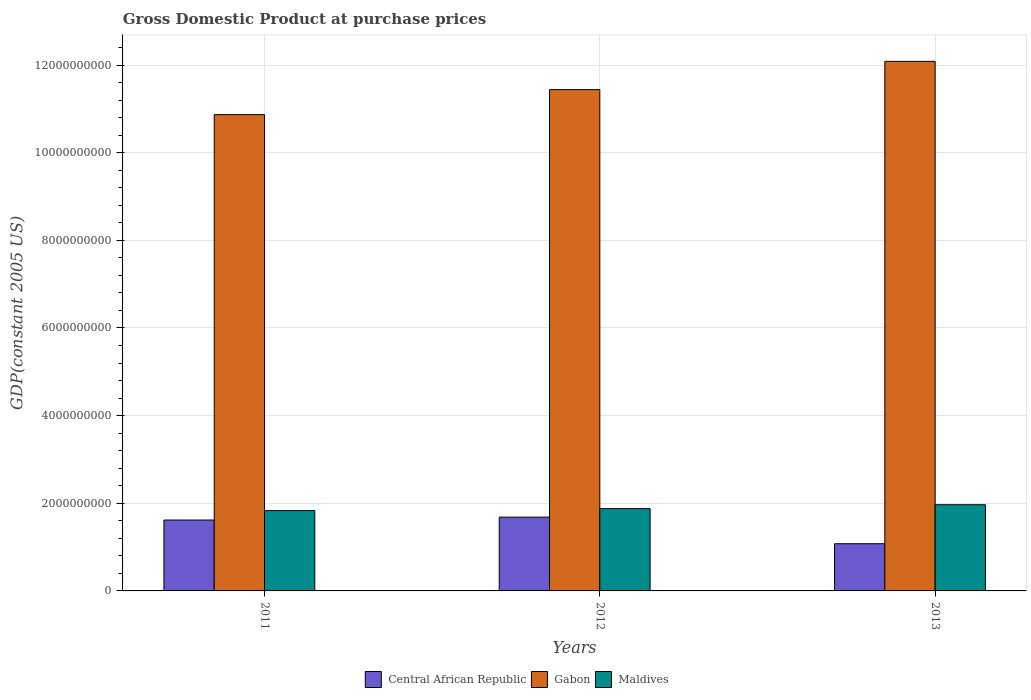How many different coloured bars are there?
Your response must be concise. 3. Are the number of bars per tick equal to the number of legend labels?
Provide a succinct answer. Yes. How many bars are there on the 1st tick from the left?
Provide a succinct answer. 3. How many bars are there on the 2nd tick from the right?
Your answer should be compact. 3. In how many cases, is the number of bars for a given year not equal to the number of legend labels?
Provide a short and direct response. 0. What is the GDP at purchase prices in Maldives in 2011?
Keep it short and to the point. 1.83e+09. Across all years, what is the maximum GDP at purchase prices in Gabon?
Provide a short and direct response. 1.21e+1. Across all years, what is the minimum GDP at purchase prices in Maldives?
Your answer should be very brief. 1.83e+09. In which year was the GDP at purchase prices in Gabon maximum?
Provide a succinct answer. 2013. In which year was the GDP at purchase prices in Gabon minimum?
Ensure brevity in your answer.  2011. What is the total GDP at purchase prices in Maldives in the graph?
Provide a short and direct response. 5.68e+09. What is the difference between the GDP at purchase prices in Maldives in 2011 and that in 2013?
Provide a short and direct response. -1.34e+08. What is the difference between the GDP at purchase prices in Maldives in 2012 and the GDP at purchase prices in Gabon in 2013?
Provide a succinct answer. -1.02e+1. What is the average GDP at purchase prices in Gabon per year?
Your answer should be compact. 1.15e+1. In the year 2011, what is the difference between the GDP at purchase prices in Central African Republic and GDP at purchase prices in Maldives?
Keep it short and to the point. -2.15e+08. In how many years, is the GDP at purchase prices in Central African Republic greater than 7600000000 US$?
Offer a very short reply. 0. What is the ratio of the GDP at purchase prices in Maldives in 2012 to that in 2013?
Your response must be concise. 0.96. Is the GDP at purchase prices in Maldives in 2011 less than that in 2012?
Provide a short and direct response. Yes. What is the difference between the highest and the second highest GDP at purchase prices in Maldives?
Offer a very short reply. 8.83e+07. What is the difference between the highest and the lowest GDP at purchase prices in Maldives?
Offer a very short reply. 1.34e+08. In how many years, is the GDP at purchase prices in Central African Republic greater than the average GDP at purchase prices in Central African Republic taken over all years?
Keep it short and to the point. 2. What does the 2nd bar from the left in 2012 represents?
Offer a very short reply. Gabon. What does the 2nd bar from the right in 2013 represents?
Offer a terse response. Gabon. Is it the case that in every year, the sum of the GDP at purchase prices in Maldives and GDP at purchase prices in Gabon is greater than the GDP at purchase prices in Central African Republic?
Your response must be concise. Yes. Are all the bars in the graph horizontal?
Make the answer very short. No. What is the difference between two consecutive major ticks on the Y-axis?
Keep it short and to the point. 2.00e+09. Are the values on the major ticks of Y-axis written in scientific E-notation?
Your answer should be compact. No. Does the graph contain any zero values?
Offer a very short reply. No. Does the graph contain grids?
Give a very brief answer. Yes. Where does the legend appear in the graph?
Your response must be concise. Bottom center. How many legend labels are there?
Ensure brevity in your answer.  3. What is the title of the graph?
Provide a short and direct response. Gross Domestic Product at purchase prices. Does "El Salvador" appear as one of the legend labels in the graph?
Provide a short and direct response. No. What is the label or title of the X-axis?
Your answer should be very brief. Years. What is the label or title of the Y-axis?
Provide a short and direct response. GDP(constant 2005 US). What is the GDP(constant 2005 US) in Central African Republic in 2011?
Ensure brevity in your answer.  1.62e+09. What is the GDP(constant 2005 US) in Gabon in 2011?
Offer a very short reply. 1.09e+1. What is the GDP(constant 2005 US) of Maldives in 2011?
Ensure brevity in your answer.  1.83e+09. What is the GDP(constant 2005 US) in Central African Republic in 2012?
Provide a short and direct response. 1.68e+09. What is the GDP(constant 2005 US) of Gabon in 2012?
Provide a short and direct response. 1.14e+1. What is the GDP(constant 2005 US) of Maldives in 2012?
Give a very brief answer. 1.88e+09. What is the GDP(constant 2005 US) in Central African Republic in 2013?
Keep it short and to the point. 1.08e+09. What is the GDP(constant 2005 US) in Gabon in 2013?
Give a very brief answer. 1.21e+1. What is the GDP(constant 2005 US) of Maldives in 2013?
Keep it short and to the point. 1.97e+09. Across all years, what is the maximum GDP(constant 2005 US) of Central African Republic?
Offer a terse response. 1.68e+09. Across all years, what is the maximum GDP(constant 2005 US) in Gabon?
Your answer should be very brief. 1.21e+1. Across all years, what is the maximum GDP(constant 2005 US) of Maldives?
Keep it short and to the point. 1.97e+09. Across all years, what is the minimum GDP(constant 2005 US) in Central African Republic?
Offer a very short reply. 1.08e+09. Across all years, what is the minimum GDP(constant 2005 US) in Gabon?
Provide a succinct answer. 1.09e+1. Across all years, what is the minimum GDP(constant 2005 US) of Maldives?
Offer a very short reply. 1.83e+09. What is the total GDP(constant 2005 US) in Central African Republic in the graph?
Offer a very short reply. 4.38e+09. What is the total GDP(constant 2005 US) in Gabon in the graph?
Provide a short and direct response. 3.44e+1. What is the total GDP(constant 2005 US) in Maldives in the graph?
Offer a terse response. 5.68e+09. What is the difference between the GDP(constant 2005 US) of Central African Republic in 2011 and that in 2012?
Keep it short and to the point. -6.65e+07. What is the difference between the GDP(constant 2005 US) of Gabon in 2011 and that in 2012?
Provide a short and direct response. -5.71e+08. What is the difference between the GDP(constant 2005 US) of Maldives in 2011 and that in 2012?
Your answer should be very brief. -4.57e+07. What is the difference between the GDP(constant 2005 US) in Central African Republic in 2011 and that in 2013?
Make the answer very short. 5.41e+08. What is the difference between the GDP(constant 2005 US) of Gabon in 2011 and that in 2013?
Keep it short and to the point. -1.22e+09. What is the difference between the GDP(constant 2005 US) of Maldives in 2011 and that in 2013?
Keep it short and to the point. -1.34e+08. What is the difference between the GDP(constant 2005 US) of Central African Republic in 2012 and that in 2013?
Ensure brevity in your answer.  6.07e+08. What is the difference between the GDP(constant 2005 US) of Gabon in 2012 and that in 2013?
Your response must be concise. -6.45e+08. What is the difference between the GDP(constant 2005 US) in Maldives in 2012 and that in 2013?
Offer a very short reply. -8.83e+07. What is the difference between the GDP(constant 2005 US) in Central African Republic in 2011 and the GDP(constant 2005 US) in Gabon in 2012?
Offer a terse response. -9.82e+09. What is the difference between the GDP(constant 2005 US) in Central African Republic in 2011 and the GDP(constant 2005 US) in Maldives in 2012?
Your answer should be very brief. -2.61e+08. What is the difference between the GDP(constant 2005 US) in Gabon in 2011 and the GDP(constant 2005 US) in Maldives in 2012?
Provide a succinct answer. 8.99e+09. What is the difference between the GDP(constant 2005 US) of Central African Republic in 2011 and the GDP(constant 2005 US) of Gabon in 2013?
Give a very brief answer. -1.05e+1. What is the difference between the GDP(constant 2005 US) in Central African Republic in 2011 and the GDP(constant 2005 US) in Maldives in 2013?
Provide a short and direct response. -3.49e+08. What is the difference between the GDP(constant 2005 US) in Gabon in 2011 and the GDP(constant 2005 US) in Maldives in 2013?
Provide a succinct answer. 8.90e+09. What is the difference between the GDP(constant 2005 US) in Central African Republic in 2012 and the GDP(constant 2005 US) in Gabon in 2013?
Keep it short and to the point. -1.04e+1. What is the difference between the GDP(constant 2005 US) of Central African Republic in 2012 and the GDP(constant 2005 US) of Maldives in 2013?
Give a very brief answer. -2.83e+08. What is the difference between the GDP(constant 2005 US) in Gabon in 2012 and the GDP(constant 2005 US) in Maldives in 2013?
Ensure brevity in your answer.  9.47e+09. What is the average GDP(constant 2005 US) of Central African Republic per year?
Provide a succinct answer. 1.46e+09. What is the average GDP(constant 2005 US) in Gabon per year?
Your answer should be compact. 1.15e+1. What is the average GDP(constant 2005 US) of Maldives per year?
Your response must be concise. 1.89e+09. In the year 2011, what is the difference between the GDP(constant 2005 US) of Central African Republic and GDP(constant 2005 US) of Gabon?
Ensure brevity in your answer.  -9.25e+09. In the year 2011, what is the difference between the GDP(constant 2005 US) of Central African Republic and GDP(constant 2005 US) of Maldives?
Your response must be concise. -2.15e+08. In the year 2011, what is the difference between the GDP(constant 2005 US) in Gabon and GDP(constant 2005 US) in Maldives?
Your answer should be very brief. 9.04e+09. In the year 2012, what is the difference between the GDP(constant 2005 US) of Central African Republic and GDP(constant 2005 US) of Gabon?
Make the answer very short. -9.76e+09. In the year 2012, what is the difference between the GDP(constant 2005 US) in Central African Republic and GDP(constant 2005 US) in Maldives?
Give a very brief answer. -1.94e+08. In the year 2012, what is the difference between the GDP(constant 2005 US) of Gabon and GDP(constant 2005 US) of Maldives?
Your response must be concise. 9.56e+09. In the year 2013, what is the difference between the GDP(constant 2005 US) of Central African Republic and GDP(constant 2005 US) of Gabon?
Offer a very short reply. -1.10e+1. In the year 2013, what is the difference between the GDP(constant 2005 US) of Central African Republic and GDP(constant 2005 US) of Maldives?
Offer a very short reply. -8.90e+08. In the year 2013, what is the difference between the GDP(constant 2005 US) of Gabon and GDP(constant 2005 US) of Maldives?
Offer a very short reply. 1.01e+1. What is the ratio of the GDP(constant 2005 US) in Central African Republic in 2011 to that in 2012?
Your answer should be compact. 0.96. What is the ratio of the GDP(constant 2005 US) of Gabon in 2011 to that in 2012?
Offer a terse response. 0.95. What is the ratio of the GDP(constant 2005 US) in Maldives in 2011 to that in 2012?
Ensure brevity in your answer.  0.98. What is the ratio of the GDP(constant 2005 US) of Central African Republic in 2011 to that in 2013?
Your response must be concise. 1.5. What is the ratio of the GDP(constant 2005 US) of Gabon in 2011 to that in 2013?
Provide a short and direct response. 0.9. What is the ratio of the GDP(constant 2005 US) in Maldives in 2011 to that in 2013?
Your answer should be compact. 0.93. What is the ratio of the GDP(constant 2005 US) in Central African Republic in 2012 to that in 2013?
Offer a terse response. 1.56. What is the ratio of the GDP(constant 2005 US) in Gabon in 2012 to that in 2013?
Provide a succinct answer. 0.95. What is the ratio of the GDP(constant 2005 US) in Maldives in 2012 to that in 2013?
Offer a very short reply. 0.96. What is the difference between the highest and the second highest GDP(constant 2005 US) in Central African Republic?
Give a very brief answer. 6.65e+07. What is the difference between the highest and the second highest GDP(constant 2005 US) of Gabon?
Your answer should be very brief. 6.45e+08. What is the difference between the highest and the second highest GDP(constant 2005 US) of Maldives?
Offer a very short reply. 8.83e+07. What is the difference between the highest and the lowest GDP(constant 2005 US) of Central African Republic?
Give a very brief answer. 6.07e+08. What is the difference between the highest and the lowest GDP(constant 2005 US) of Gabon?
Make the answer very short. 1.22e+09. What is the difference between the highest and the lowest GDP(constant 2005 US) in Maldives?
Provide a succinct answer. 1.34e+08. 